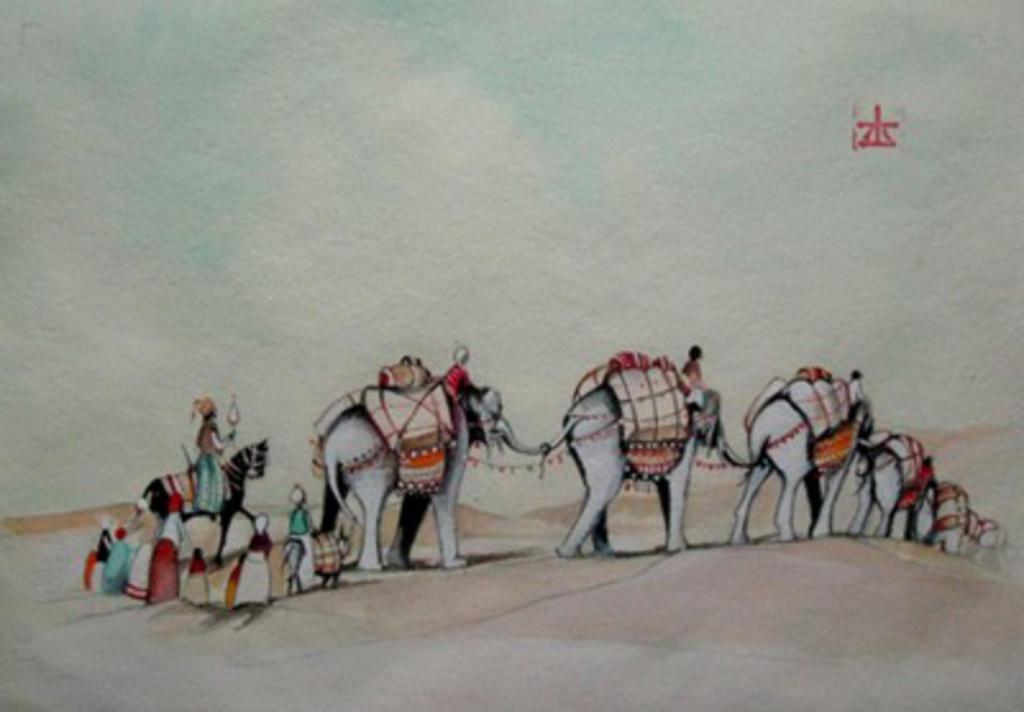What is depicted in the picture? There is a drawing in the picture. What animals are included in the drawing? There are elephants in the drawing. Are there any human figures in the drawing? Yes, there are people in the drawing. How many books can be seen in the drawing? There are no books present in the drawing; it features elephants and people. Are there any babies visible in the drawing? There is no mention of babies in the drawing; it includes elephants and people. 